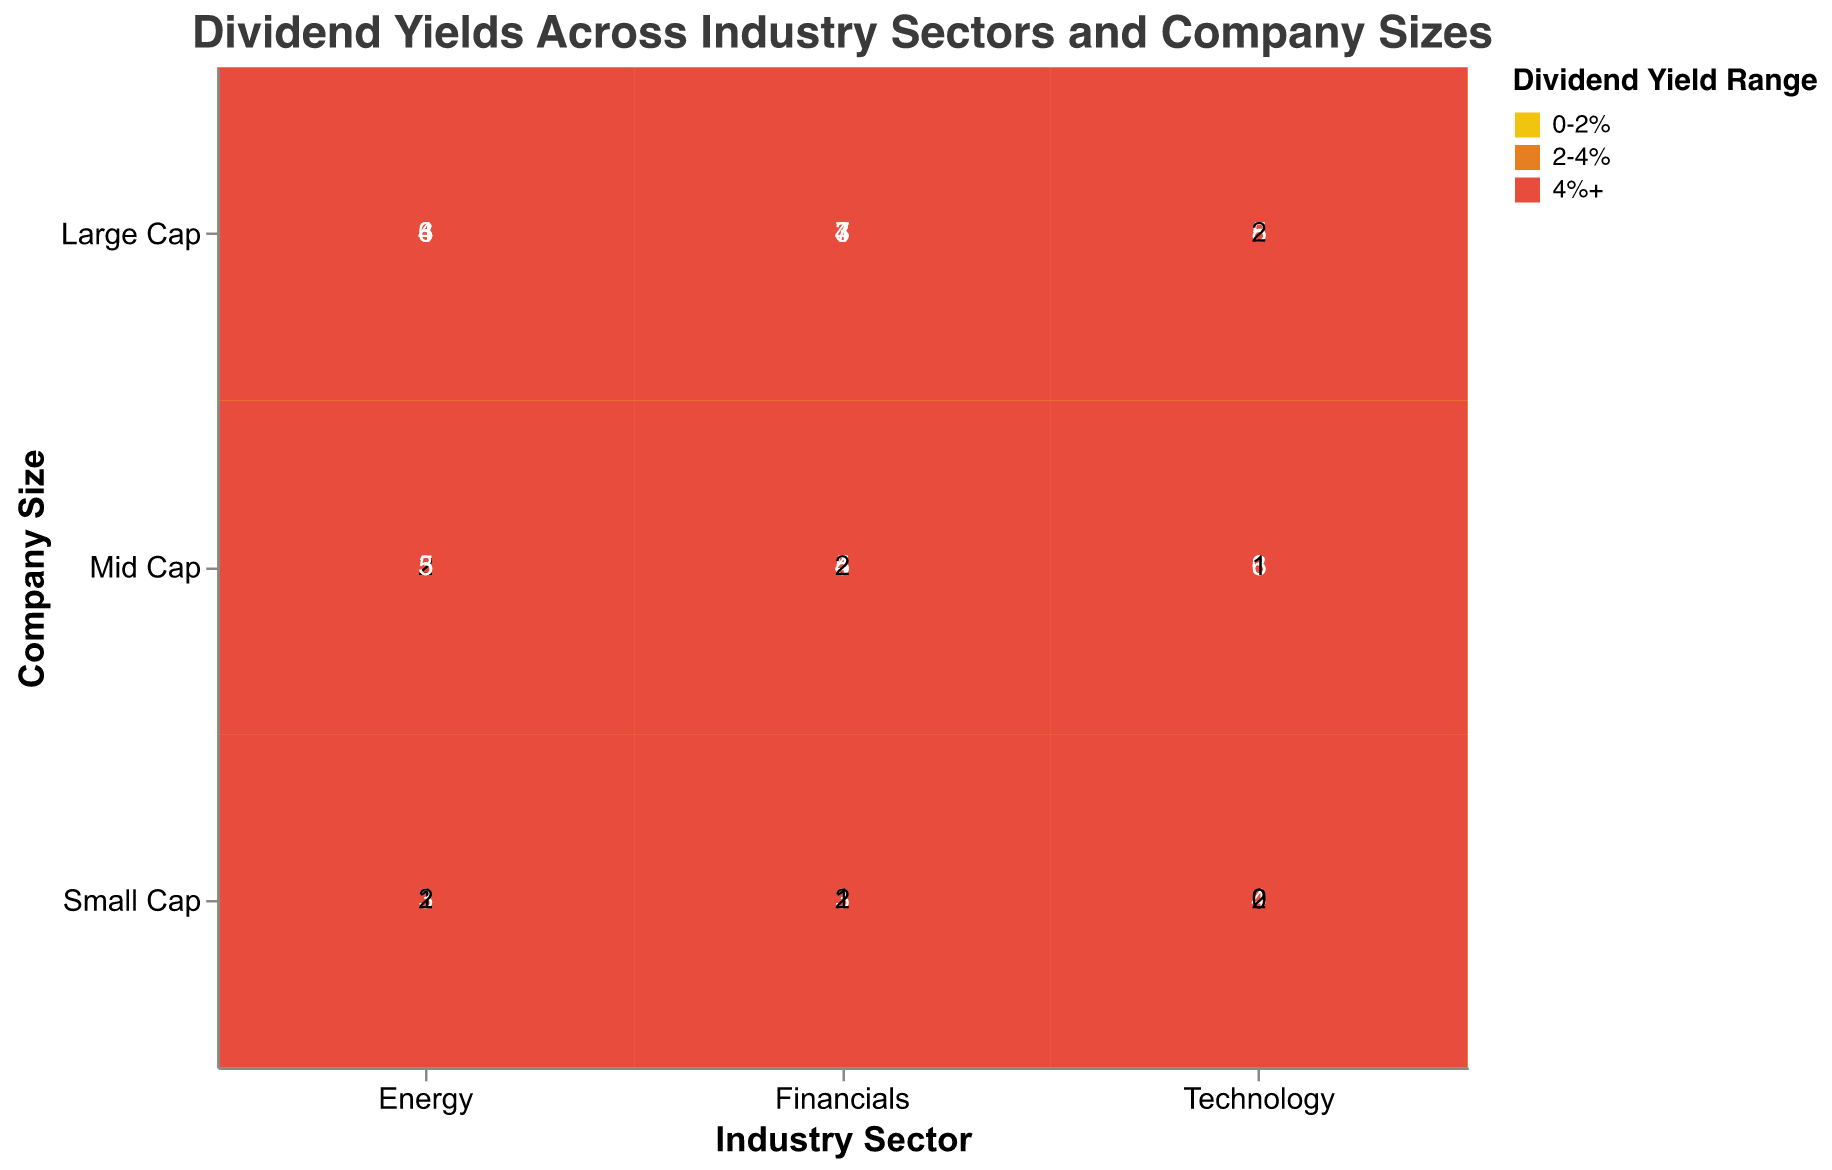What is the title of the figure? The title is usually located at the top of the chart and gives a brief description of the data being presented. In this case, the figure's title "Dividend Yields Across Industry Sectors and Company Sizes" is clearly displayed.
Answer: Dividend Yields Across Industry Sectors and Company Sizes Which company size in the Technology industry has the highest count in the "0-2%" dividend yield range? To find this, look at the Technology sector and compare the counts of the "0-2%" dividend yield range across different company sizes. Large Cap has a count of 8, Mid Cap has a count of 6, and Small Cap has a count of 4.
Answer: Large Cap How many companies in the Financials sector have dividend yields of "4%+" across all company sizes? Sum the counts of the "4%+" dividend yield range for the Financials sector across all company sizes. Large Cap has 3, Mid Cap has 2, and Small Cap has 1. Therefore, 3 + 2 + 1 = 6.
Answer: 6 Which industry has the largest number of companies with dividend yields in the "2-4%" range for Large Cap companies? Compare the counts for the "2-4%" dividend yield range in the Large Cap category across all industries. Technology has 5, Energy has 6, and Financials has 7. The Financials sector has the largest count.
Answer: Financials Is the count of Large Cap companies with dividend yields of "0-2%" higher in the Technology sector or the Financials sector? Compare the counts of Large Cap companies with "0-2%" dividend yields in both sectors. Technology has 8, whereas Financials have 4.
Answer: Technology What is the distribution of companies in the Energy sector with "4%+" dividend yields by company size? Examine the counts for each company size within the Energy sector for the "4%+" dividend yield range. Large Cap has 4, Mid Cap has 3, and Small Cap has 2.
Answer: Large Cap: 4, Mid Cap: 3, Small Cap: 2 In which sector do Mid Cap companies show the highest number of "2-4%" dividend yields? Compare the counts of the "2-4%" dividend yield for Mid Cap companies across all sectors. Technology has 3, Energy has 5, and Financials have 4. The Energy sector has the highest count.
Answer: Energy Is there any sector where Small Cap companies have no "4%+" dividend yields? Observe the "4%+" dividend yield range for Small Cap companies across all sectors. The Technology sector has a count of 0, while Energy and Financials have counts greater than 0.
Answer: Technology How many total companies in the Energy sector have dividend yields in the "0-2%" range? Sum the counts for the "0-2%" dividend yield range across all company sizes in the Energy sector. Large Cap has 3, Mid Cap has 2, and Small Cap has 1. Therefore, 3 + 2 + 1 = 6.
Answer: 6 